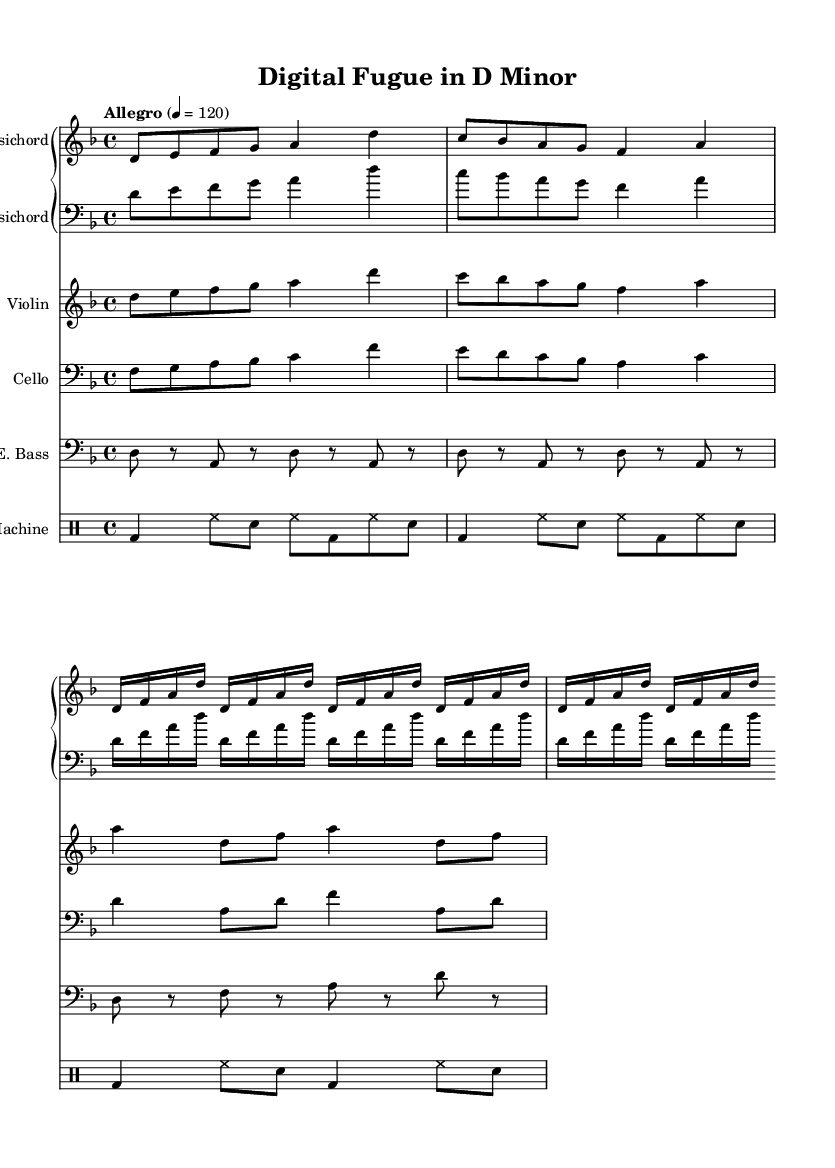What is the key signature of this music? The key signature is D minor, which has one flat (B flat). This is indicated at the beginning of the staff before the notes.
Answer: D minor What is the time signature of this piece? The time signature is 4/4, which means there are four beats in a measure and the quarter note gets one beat. This is represented indicated at the beginning of the music.
Answer: 4/4 What is the tempo marking for this piece? The tempo marking states "Allegro," which indicates a lively and fast tempo. The specific metronome marking is also provided, showing it should be played at a speed of 120 beats per minute.
Answer: Allegro How many measures are in the cello part? By counting the individual measures in the cello staff, there are a total of 6 measures. Each measure is separated by vertical lines; this makes it easy to visually count them.
Answer: 6 Which instrument has a staff labeled "E. Bass"? The staff labeled "E. Bass" indicates an electronic bass, which is denoted in the header of that particular staff. The designation reflects the presence of modern sampling techniques.
Answer: Electronic Bass What type of rhythm do the drum machine notes primarily use? The drum machine uses a combination of bass drum, hi-hat, and snare notes, but the predominant rhythmic pattern is mainly eighth notes and quarter notes. The repetition of these patterns can be observed across the measures.
Answer: Eighth notes 